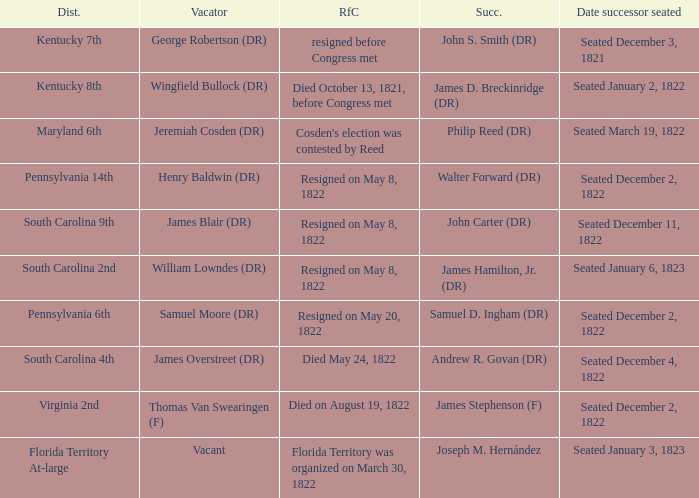Who is the vacator when south carolina 4th is the district? James Overstreet (DR). 